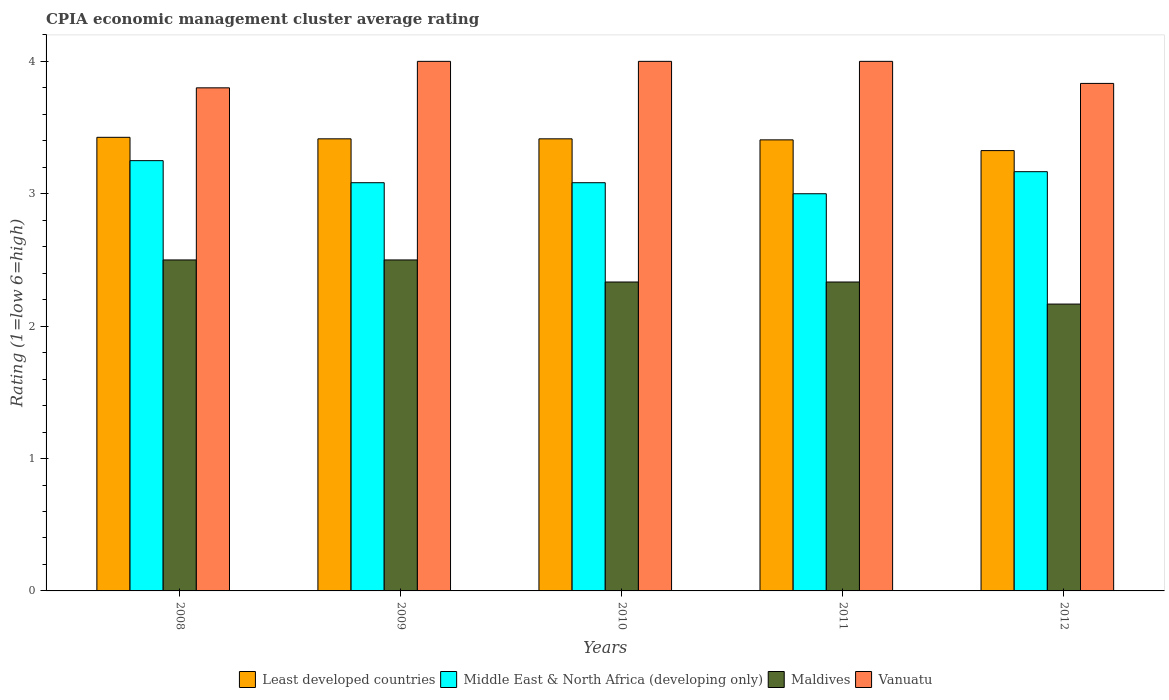How many different coloured bars are there?
Your response must be concise. 4. What is the CPIA rating in Vanuatu in 2011?
Provide a short and direct response. 4. Across all years, what is the maximum CPIA rating in Maldives?
Provide a succinct answer. 2.5. Across all years, what is the minimum CPIA rating in Maldives?
Your response must be concise. 2.17. In which year was the CPIA rating in Vanuatu maximum?
Provide a succinct answer. 2009. In which year was the CPIA rating in Vanuatu minimum?
Offer a very short reply. 2008. What is the total CPIA rating in Least developed countries in the graph?
Keep it short and to the point. 16.99. What is the difference between the CPIA rating in Vanuatu in 2010 and that in 2012?
Your response must be concise. 0.17. What is the average CPIA rating in Maldives per year?
Provide a short and direct response. 2.37. In the year 2011, what is the difference between the CPIA rating in Middle East & North Africa (developing only) and CPIA rating in Least developed countries?
Keep it short and to the point. -0.41. In how many years, is the CPIA rating in Least developed countries greater than 1.6?
Give a very brief answer. 5. What is the ratio of the CPIA rating in Maldives in 2010 to that in 2012?
Your answer should be compact. 1.08. What is the difference between the highest and the second highest CPIA rating in Least developed countries?
Your response must be concise. 0.01. Is the sum of the CPIA rating in Least developed countries in 2011 and 2012 greater than the maximum CPIA rating in Middle East & North Africa (developing only) across all years?
Provide a succinct answer. Yes. What does the 1st bar from the left in 2008 represents?
Your response must be concise. Least developed countries. What does the 4th bar from the right in 2010 represents?
Keep it short and to the point. Least developed countries. How many bars are there?
Provide a succinct answer. 20. Are all the bars in the graph horizontal?
Provide a short and direct response. No. How many years are there in the graph?
Your answer should be very brief. 5. What is the title of the graph?
Offer a terse response. CPIA economic management cluster average rating. Does "Congo (Republic)" appear as one of the legend labels in the graph?
Keep it short and to the point. No. What is the label or title of the X-axis?
Your answer should be very brief. Years. What is the label or title of the Y-axis?
Your response must be concise. Rating (1=low 6=high). What is the Rating (1=low 6=high) in Least developed countries in 2008?
Keep it short and to the point. 3.43. What is the Rating (1=low 6=high) in Middle East & North Africa (developing only) in 2008?
Make the answer very short. 3.25. What is the Rating (1=low 6=high) in Maldives in 2008?
Offer a terse response. 2.5. What is the Rating (1=low 6=high) in Vanuatu in 2008?
Provide a short and direct response. 3.8. What is the Rating (1=low 6=high) in Least developed countries in 2009?
Provide a succinct answer. 3.41. What is the Rating (1=low 6=high) in Middle East & North Africa (developing only) in 2009?
Make the answer very short. 3.08. What is the Rating (1=low 6=high) in Maldives in 2009?
Your answer should be very brief. 2.5. What is the Rating (1=low 6=high) in Least developed countries in 2010?
Give a very brief answer. 3.41. What is the Rating (1=low 6=high) of Middle East & North Africa (developing only) in 2010?
Provide a succinct answer. 3.08. What is the Rating (1=low 6=high) in Maldives in 2010?
Offer a very short reply. 2.33. What is the Rating (1=low 6=high) in Least developed countries in 2011?
Your answer should be very brief. 3.41. What is the Rating (1=low 6=high) in Middle East & North Africa (developing only) in 2011?
Offer a terse response. 3. What is the Rating (1=low 6=high) of Maldives in 2011?
Ensure brevity in your answer.  2.33. What is the Rating (1=low 6=high) in Vanuatu in 2011?
Provide a short and direct response. 4. What is the Rating (1=low 6=high) in Least developed countries in 2012?
Offer a terse response. 3.33. What is the Rating (1=low 6=high) in Middle East & North Africa (developing only) in 2012?
Your answer should be very brief. 3.17. What is the Rating (1=low 6=high) of Maldives in 2012?
Make the answer very short. 2.17. What is the Rating (1=low 6=high) of Vanuatu in 2012?
Your answer should be very brief. 3.83. Across all years, what is the maximum Rating (1=low 6=high) of Least developed countries?
Ensure brevity in your answer.  3.43. Across all years, what is the maximum Rating (1=low 6=high) of Middle East & North Africa (developing only)?
Your answer should be very brief. 3.25. Across all years, what is the maximum Rating (1=low 6=high) of Vanuatu?
Keep it short and to the point. 4. Across all years, what is the minimum Rating (1=low 6=high) of Least developed countries?
Make the answer very short. 3.33. Across all years, what is the minimum Rating (1=low 6=high) of Maldives?
Provide a short and direct response. 2.17. What is the total Rating (1=low 6=high) in Least developed countries in the graph?
Offer a very short reply. 16.99. What is the total Rating (1=low 6=high) in Middle East & North Africa (developing only) in the graph?
Keep it short and to the point. 15.58. What is the total Rating (1=low 6=high) of Maldives in the graph?
Give a very brief answer. 11.83. What is the total Rating (1=low 6=high) in Vanuatu in the graph?
Make the answer very short. 19.63. What is the difference between the Rating (1=low 6=high) of Least developed countries in 2008 and that in 2009?
Your response must be concise. 0.01. What is the difference between the Rating (1=low 6=high) in Least developed countries in 2008 and that in 2010?
Offer a very short reply. 0.01. What is the difference between the Rating (1=low 6=high) of Middle East & North Africa (developing only) in 2008 and that in 2010?
Your response must be concise. 0.17. What is the difference between the Rating (1=low 6=high) of Vanuatu in 2008 and that in 2010?
Your answer should be compact. -0.2. What is the difference between the Rating (1=low 6=high) in Least developed countries in 2008 and that in 2011?
Provide a succinct answer. 0.02. What is the difference between the Rating (1=low 6=high) in Maldives in 2008 and that in 2011?
Give a very brief answer. 0.17. What is the difference between the Rating (1=low 6=high) of Least developed countries in 2008 and that in 2012?
Your response must be concise. 0.1. What is the difference between the Rating (1=low 6=high) in Middle East & North Africa (developing only) in 2008 and that in 2012?
Ensure brevity in your answer.  0.08. What is the difference between the Rating (1=low 6=high) in Vanuatu in 2008 and that in 2012?
Your response must be concise. -0.03. What is the difference between the Rating (1=low 6=high) in Least developed countries in 2009 and that in 2010?
Ensure brevity in your answer.  0. What is the difference between the Rating (1=low 6=high) of Middle East & North Africa (developing only) in 2009 and that in 2010?
Provide a succinct answer. 0. What is the difference between the Rating (1=low 6=high) of Vanuatu in 2009 and that in 2010?
Your answer should be very brief. 0. What is the difference between the Rating (1=low 6=high) of Least developed countries in 2009 and that in 2011?
Provide a short and direct response. 0.01. What is the difference between the Rating (1=low 6=high) of Middle East & North Africa (developing only) in 2009 and that in 2011?
Offer a very short reply. 0.08. What is the difference between the Rating (1=low 6=high) of Maldives in 2009 and that in 2011?
Offer a terse response. 0.17. What is the difference between the Rating (1=low 6=high) in Least developed countries in 2009 and that in 2012?
Your answer should be compact. 0.09. What is the difference between the Rating (1=low 6=high) of Middle East & North Africa (developing only) in 2009 and that in 2012?
Ensure brevity in your answer.  -0.08. What is the difference between the Rating (1=low 6=high) in Least developed countries in 2010 and that in 2011?
Your response must be concise. 0.01. What is the difference between the Rating (1=low 6=high) of Middle East & North Africa (developing only) in 2010 and that in 2011?
Keep it short and to the point. 0.08. What is the difference between the Rating (1=low 6=high) of Least developed countries in 2010 and that in 2012?
Offer a very short reply. 0.09. What is the difference between the Rating (1=low 6=high) in Middle East & North Africa (developing only) in 2010 and that in 2012?
Your answer should be very brief. -0.08. What is the difference between the Rating (1=low 6=high) in Maldives in 2010 and that in 2012?
Make the answer very short. 0.17. What is the difference between the Rating (1=low 6=high) of Vanuatu in 2010 and that in 2012?
Offer a very short reply. 0.17. What is the difference between the Rating (1=low 6=high) in Least developed countries in 2011 and that in 2012?
Give a very brief answer. 0.08. What is the difference between the Rating (1=low 6=high) of Maldives in 2011 and that in 2012?
Offer a terse response. 0.17. What is the difference between the Rating (1=low 6=high) in Vanuatu in 2011 and that in 2012?
Offer a very short reply. 0.17. What is the difference between the Rating (1=low 6=high) of Least developed countries in 2008 and the Rating (1=low 6=high) of Middle East & North Africa (developing only) in 2009?
Ensure brevity in your answer.  0.34. What is the difference between the Rating (1=low 6=high) in Least developed countries in 2008 and the Rating (1=low 6=high) in Maldives in 2009?
Give a very brief answer. 0.93. What is the difference between the Rating (1=low 6=high) of Least developed countries in 2008 and the Rating (1=low 6=high) of Vanuatu in 2009?
Provide a succinct answer. -0.57. What is the difference between the Rating (1=low 6=high) in Middle East & North Africa (developing only) in 2008 and the Rating (1=low 6=high) in Vanuatu in 2009?
Keep it short and to the point. -0.75. What is the difference between the Rating (1=low 6=high) in Maldives in 2008 and the Rating (1=low 6=high) in Vanuatu in 2009?
Make the answer very short. -1.5. What is the difference between the Rating (1=low 6=high) in Least developed countries in 2008 and the Rating (1=low 6=high) in Middle East & North Africa (developing only) in 2010?
Provide a short and direct response. 0.34. What is the difference between the Rating (1=low 6=high) of Least developed countries in 2008 and the Rating (1=low 6=high) of Maldives in 2010?
Keep it short and to the point. 1.09. What is the difference between the Rating (1=low 6=high) in Least developed countries in 2008 and the Rating (1=low 6=high) in Vanuatu in 2010?
Provide a short and direct response. -0.57. What is the difference between the Rating (1=low 6=high) of Middle East & North Africa (developing only) in 2008 and the Rating (1=low 6=high) of Maldives in 2010?
Keep it short and to the point. 0.92. What is the difference between the Rating (1=low 6=high) of Middle East & North Africa (developing only) in 2008 and the Rating (1=low 6=high) of Vanuatu in 2010?
Provide a short and direct response. -0.75. What is the difference between the Rating (1=low 6=high) of Least developed countries in 2008 and the Rating (1=low 6=high) of Middle East & North Africa (developing only) in 2011?
Your answer should be compact. 0.43. What is the difference between the Rating (1=low 6=high) of Least developed countries in 2008 and the Rating (1=low 6=high) of Maldives in 2011?
Your answer should be compact. 1.09. What is the difference between the Rating (1=low 6=high) in Least developed countries in 2008 and the Rating (1=low 6=high) in Vanuatu in 2011?
Ensure brevity in your answer.  -0.57. What is the difference between the Rating (1=low 6=high) in Middle East & North Africa (developing only) in 2008 and the Rating (1=low 6=high) in Maldives in 2011?
Keep it short and to the point. 0.92. What is the difference between the Rating (1=low 6=high) in Middle East & North Africa (developing only) in 2008 and the Rating (1=low 6=high) in Vanuatu in 2011?
Give a very brief answer. -0.75. What is the difference between the Rating (1=low 6=high) in Maldives in 2008 and the Rating (1=low 6=high) in Vanuatu in 2011?
Offer a terse response. -1.5. What is the difference between the Rating (1=low 6=high) in Least developed countries in 2008 and the Rating (1=low 6=high) in Middle East & North Africa (developing only) in 2012?
Ensure brevity in your answer.  0.26. What is the difference between the Rating (1=low 6=high) in Least developed countries in 2008 and the Rating (1=low 6=high) in Maldives in 2012?
Offer a terse response. 1.26. What is the difference between the Rating (1=low 6=high) in Least developed countries in 2008 and the Rating (1=low 6=high) in Vanuatu in 2012?
Ensure brevity in your answer.  -0.41. What is the difference between the Rating (1=low 6=high) in Middle East & North Africa (developing only) in 2008 and the Rating (1=low 6=high) in Maldives in 2012?
Keep it short and to the point. 1.08. What is the difference between the Rating (1=low 6=high) of Middle East & North Africa (developing only) in 2008 and the Rating (1=low 6=high) of Vanuatu in 2012?
Offer a very short reply. -0.58. What is the difference between the Rating (1=low 6=high) of Maldives in 2008 and the Rating (1=low 6=high) of Vanuatu in 2012?
Your response must be concise. -1.33. What is the difference between the Rating (1=low 6=high) in Least developed countries in 2009 and the Rating (1=low 6=high) in Middle East & North Africa (developing only) in 2010?
Provide a succinct answer. 0.33. What is the difference between the Rating (1=low 6=high) in Least developed countries in 2009 and the Rating (1=low 6=high) in Maldives in 2010?
Your answer should be very brief. 1.08. What is the difference between the Rating (1=low 6=high) in Least developed countries in 2009 and the Rating (1=low 6=high) in Vanuatu in 2010?
Ensure brevity in your answer.  -0.59. What is the difference between the Rating (1=low 6=high) of Middle East & North Africa (developing only) in 2009 and the Rating (1=low 6=high) of Maldives in 2010?
Ensure brevity in your answer.  0.75. What is the difference between the Rating (1=low 6=high) in Middle East & North Africa (developing only) in 2009 and the Rating (1=low 6=high) in Vanuatu in 2010?
Ensure brevity in your answer.  -0.92. What is the difference between the Rating (1=low 6=high) in Least developed countries in 2009 and the Rating (1=low 6=high) in Middle East & North Africa (developing only) in 2011?
Offer a terse response. 0.41. What is the difference between the Rating (1=low 6=high) of Least developed countries in 2009 and the Rating (1=low 6=high) of Maldives in 2011?
Offer a very short reply. 1.08. What is the difference between the Rating (1=low 6=high) in Least developed countries in 2009 and the Rating (1=low 6=high) in Vanuatu in 2011?
Ensure brevity in your answer.  -0.59. What is the difference between the Rating (1=low 6=high) of Middle East & North Africa (developing only) in 2009 and the Rating (1=low 6=high) of Vanuatu in 2011?
Keep it short and to the point. -0.92. What is the difference between the Rating (1=low 6=high) in Maldives in 2009 and the Rating (1=low 6=high) in Vanuatu in 2011?
Your answer should be compact. -1.5. What is the difference between the Rating (1=low 6=high) in Least developed countries in 2009 and the Rating (1=low 6=high) in Middle East & North Africa (developing only) in 2012?
Your answer should be compact. 0.25. What is the difference between the Rating (1=low 6=high) in Least developed countries in 2009 and the Rating (1=low 6=high) in Maldives in 2012?
Make the answer very short. 1.25. What is the difference between the Rating (1=low 6=high) in Least developed countries in 2009 and the Rating (1=low 6=high) in Vanuatu in 2012?
Ensure brevity in your answer.  -0.42. What is the difference between the Rating (1=low 6=high) in Middle East & North Africa (developing only) in 2009 and the Rating (1=low 6=high) in Maldives in 2012?
Offer a terse response. 0.92. What is the difference between the Rating (1=low 6=high) of Middle East & North Africa (developing only) in 2009 and the Rating (1=low 6=high) of Vanuatu in 2012?
Make the answer very short. -0.75. What is the difference between the Rating (1=low 6=high) of Maldives in 2009 and the Rating (1=low 6=high) of Vanuatu in 2012?
Provide a short and direct response. -1.33. What is the difference between the Rating (1=low 6=high) of Least developed countries in 2010 and the Rating (1=low 6=high) of Middle East & North Africa (developing only) in 2011?
Ensure brevity in your answer.  0.41. What is the difference between the Rating (1=low 6=high) in Least developed countries in 2010 and the Rating (1=low 6=high) in Maldives in 2011?
Give a very brief answer. 1.08. What is the difference between the Rating (1=low 6=high) in Least developed countries in 2010 and the Rating (1=low 6=high) in Vanuatu in 2011?
Provide a short and direct response. -0.59. What is the difference between the Rating (1=low 6=high) in Middle East & North Africa (developing only) in 2010 and the Rating (1=low 6=high) in Vanuatu in 2011?
Your response must be concise. -0.92. What is the difference between the Rating (1=low 6=high) of Maldives in 2010 and the Rating (1=low 6=high) of Vanuatu in 2011?
Make the answer very short. -1.67. What is the difference between the Rating (1=low 6=high) of Least developed countries in 2010 and the Rating (1=low 6=high) of Middle East & North Africa (developing only) in 2012?
Your response must be concise. 0.25. What is the difference between the Rating (1=low 6=high) in Least developed countries in 2010 and the Rating (1=low 6=high) in Maldives in 2012?
Offer a terse response. 1.25. What is the difference between the Rating (1=low 6=high) of Least developed countries in 2010 and the Rating (1=low 6=high) of Vanuatu in 2012?
Your answer should be very brief. -0.42. What is the difference between the Rating (1=low 6=high) in Middle East & North Africa (developing only) in 2010 and the Rating (1=low 6=high) in Maldives in 2012?
Your answer should be very brief. 0.92. What is the difference between the Rating (1=low 6=high) of Middle East & North Africa (developing only) in 2010 and the Rating (1=low 6=high) of Vanuatu in 2012?
Make the answer very short. -0.75. What is the difference between the Rating (1=low 6=high) in Maldives in 2010 and the Rating (1=low 6=high) in Vanuatu in 2012?
Provide a short and direct response. -1.5. What is the difference between the Rating (1=low 6=high) of Least developed countries in 2011 and the Rating (1=low 6=high) of Middle East & North Africa (developing only) in 2012?
Your answer should be very brief. 0.24. What is the difference between the Rating (1=low 6=high) in Least developed countries in 2011 and the Rating (1=low 6=high) in Maldives in 2012?
Your answer should be compact. 1.24. What is the difference between the Rating (1=low 6=high) in Least developed countries in 2011 and the Rating (1=low 6=high) in Vanuatu in 2012?
Offer a very short reply. -0.43. What is the difference between the Rating (1=low 6=high) in Middle East & North Africa (developing only) in 2011 and the Rating (1=low 6=high) in Maldives in 2012?
Make the answer very short. 0.83. What is the difference between the Rating (1=low 6=high) in Middle East & North Africa (developing only) in 2011 and the Rating (1=low 6=high) in Vanuatu in 2012?
Your answer should be very brief. -0.83. What is the average Rating (1=low 6=high) of Least developed countries per year?
Provide a succinct answer. 3.4. What is the average Rating (1=low 6=high) of Middle East & North Africa (developing only) per year?
Give a very brief answer. 3.12. What is the average Rating (1=low 6=high) in Maldives per year?
Offer a terse response. 2.37. What is the average Rating (1=low 6=high) of Vanuatu per year?
Offer a terse response. 3.93. In the year 2008, what is the difference between the Rating (1=low 6=high) of Least developed countries and Rating (1=low 6=high) of Middle East & North Africa (developing only)?
Provide a succinct answer. 0.18. In the year 2008, what is the difference between the Rating (1=low 6=high) in Least developed countries and Rating (1=low 6=high) in Maldives?
Offer a very short reply. 0.93. In the year 2008, what is the difference between the Rating (1=low 6=high) in Least developed countries and Rating (1=low 6=high) in Vanuatu?
Offer a terse response. -0.37. In the year 2008, what is the difference between the Rating (1=low 6=high) in Middle East & North Africa (developing only) and Rating (1=low 6=high) in Maldives?
Provide a succinct answer. 0.75. In the year 2008, what is the difference between the Rating (1=low 6=high) in Middle East & North Africa (developing only) and Rating (1=low 6=high) in Vanuatu?
Offer a very short reply. -0.55. In the year 2009, what is the difference between the Rating (1=low 6=high) of Least developed countries and Rating (1=low 6=high) of Middle East & North Africa (developing only)?
Offer a very short reply. 0.33. In the year 2009, what is the difference between the Rating (1=low 6=high) of Least developed countries and Rating (1=low 6=high) of Maldives?
Keep it short and to the point. 0.91. In the year 2009, what is the difference between the Rating (1=low 6=high) in Least developed countries and Rating (1=low 6=high) in Vanuatu?
Provide a short and direct response. -0.59. In the year 2009, what is the difference between the Rating (1=low 6=high) of Middle East & North Africa (developing only) and Rating (1=low 6=high) of Maldives?
Provide a short and direct response. 0.58. In the year 2009, what is the difference between the Rating (1=low 6=high) in Middle East & North Africa (developing only) and Rating (1=low 6=high) in Vanuatu?
Ensure brevity in your answer.  -0.92. In the year 2010, what is the difference between the Rating (1=low 6=high) of Least developed countries and Rating (1=low 6=high) of Middle East & North Africa (developing only)?
Make the answer very short. 0.33. In the year 2010, what is the difference between the Rating (1=low 6=high) of Least developed countries and Rating (1=low 6=high) of Maldives?
Provide a short and direct response. 1.08. In the year 2010, what is the difference between the Rating (1=low 6=high) of Least developed countries and Rating (1=low 6=high) of Vanuatu?
Ensure brevity in your answer.  -0.59. In the year 2010, what is the difference between the Rating (1=low 6=high) in Middle East & North Africa (developing only) and Rating (1=low 6=high) in Vanuatu?
Offer a very short reply. -0.92. In the year 2010, what is the difference between the Rating (1=low 6=high) in Maldives and Rating (1=low 6=high) in Vanuatu?
Provide a short and direct response. -1.67. In the year 2011, what is the difference between the Rating (1=low 6=high) of Least developed countries and Rating (1=low 6=high) of Middle East & North Africa (developing only)?
Provide a succinct answer. 0.41. In the year 2011, what is the difference between the Rating (1=low 6=high) of Least developed countries and Rating (1=low 6=high) of Maldives?
Offer a terse response. 1.07. In the year 2011, what is the difference between the Rating (1=low 6=high) in Least developed countries and Rating (1=low 6=high) in Vanuatu?
Ensure brevity in your answer.  -0.59. In the year 2011, what is the difference between the Rating (1=low 6=high) in Middle East & North Africa (developing only) and Rating (1=low 6=high) in Vanuatu?
Offer a very short reply. -1. In the year 2011, what is the difference between the Rating (1=low 6=high) in Maldives and Rating (1=low 6=high) in Vanuatu?
Provide a short and direct response. -1.67. In the year 2012, what is the difference between the Rating (1=low 6=high) in Least developed countries and Rating (1=low 6=high) in Middle East & North Africa (developing only)?
Your answer should be very brief. 0.16. In the year 2012, what is the difference between the Rating (1=low 6=high) in Least developed countries and Rating (1=low 6=high) in Maldives?
Offer a terse response. 1.16. In the year 2012, what is the difference between the Rating (1=low 6=high) of Least developed countries and Rating (1=low 6=high) of Vanuatu?
Your answer should be very brief. -0.51. In the year 2012, what is the difference between the Rating (1=low 6=high) of Maldives and Rating (1=low 6=high) of Vanuatu?
Give a very brief answer. -1.67. What is the ratio of the Rating (1=low 6=high) of Middle East & North Africa (developing only) in 2008 to that in 2009?
Provide a short and direct response. 1.05. What is the ratio of the Rating (1=low 6=high) in Maldives in 2008 to that in 2009?
Provide a succinct answer. 1. What is the ratio of the Rating (1=low 6=high) in Vanuatu in 2008 to that in 2009?
Offer a terse response. 0.95. What is the ratio of the Rating (1=low 6=high) of Middle East & North Africa (developing only) in 2008 to that in 2010?
Your response must be concise. 1.05. What is the ratio of the Rating (1=low 6=high) in Maldives in 2008 to that in 2010?
Offer a terse response. 1.07. What is the ratio of the Rating (1=low 6=high) of Vanuatu in 2008 to that in 2010?
Provide a short and direct response. 0.95. What is the ratio of the Rating (1=low 6=high) of Least developed countries in 2008 to that in 2011?
Make the answer very short. 1.01. What is the ratio of the Rating (1=low 6=high) in Middle East & North Africa (developing only) in 2008 to that in 2011?
Offer a terse response. 1.08. What is the ratio of the Rating (1=low 6=high) in Maldives in 2008 to that in 2011?
Your answer should be very brief. 1.07. What is the ratio of the Rating (1=low 6=high) in Vanuatu in 2008 to that in 2011?
Your response must be concise. 0.95. What is the ratio of the Rating (1=low 6=high) in Least developed countries in 2008 to that in 2012?
Provide a short and direct response. 1.03. What is the ratio of the Rating (1=low 6=high) in Middle East & North Africa (developing only) in 2008 to that in 2012?
Your response must be concise. 1.03. What is the ratio of the Rating (1=low 6=high) of Maldives in 2008 to that in 2012?
Make the answer very short. 1.15. What is the ratio of the Rating (1=low 6=high) in Vanuatu in 2008 to that in 2012?
Offer a terse response. 0.99. What is the ratio of the Rating (1=low 6=high) in Middle East & North Africa (developing only) in 2009 to that in 2010?
Offer a terse response. 1. What is the ratio of the Rating (1=low 6=high) in Maldives in 2009 to that in 2010?
Your answer should be very brief. 1.07. What is the ratio of the Rating (1=low 6=high) in Vanuatu in 2009 to that in 2010?
Provide a short and direct response. 1. What is the ratio of the Rating (1=low 6=high) of Least developed countries in 2009 to that in 2011?
Keep it short and to the point. 1. What is the ratio of the Rating (1=low 6=high) of Middle East & North Africa (developing only) in 2009 to that in 2011?
Provide a succinct answer. 1.03. What is the ratio of the Rating (1=low 6=high) in Maldives in 2009 to that in 2011?
Your response must be concise. 1.07. What is the ratio of the Rating (1=low 6=high) in Least developed countries in 2009 to that in 2012?
Offer a very short reply. 1.03. What is the ratio of the Rating (1=low 6=high) in Middle East & North Africa (developing only) in 2009 to that in 2012?
Offer a very short reply. 0.97. What is the ratio of the Rating (1=low 6=high) in Maldives in 2009 to that in 2012?
Offer a very short reply. 1.15. What is the ratio of the Rating (1=low 6=high) of Vanuatu in 2009 to that in 2012?
Offer a terse response. 1.04. What is the ratio of the Rating (1=low 6=high) of Least developed countries in 2010 to that in 2011?
Provide a succinct answer. 1. What is the ratio of the Rating (1=low 6=high) of Middle East & North Africa (developing only) in 2010 to that in 2011?
Make the answer very short. 1.03. What is the ratio of the Rating (1=low 6=high) of Least developed countries in 2010 to that in 2012?
Provide a succinct answer. 1.03. What is the ratio of the Rating (1=low 6=high) of Middle East & North Africa (developing only) in 2010 to that in 2012?
Offer a terse response. 0.97. What is the ratio of the Rating (1=low 6=high) of Vanuatu in 2010 to that in 2012?
Offer a terse response. 1.04. What is the ratio of the Rating (1=low 6=high) in Least developed countries in 2011 to that in 2012?
Make the answer very short. 1.02. What is the ratio of the Rating (1=low 6=high) in Vanuatu in 2011 to that in 2012?
Provide a succinct answer. 1.04. What is the difference between the highest and the second highest Rating (1=low 6=high) of Least developed countries?
Provide a short and direct response. 0.01. What is the difference between the highest and the second highest Rating (1=low 6=high) of Middle East & North Africa (developing only)?
Your answer should be compact. 0.08. What is the difference between the highest and the second highest Rating (1=low 6=high) of Maldives?
Offer a very short reply. 0. What is the difference between the highest and the lowest Rating (1=low 6=high) of Least developed countries?
Offer a very short reply. 0.1. What is the difference between the highest and the lowest Rating (1=low 6=high) in Maldives?
Provide a short and direct response. 0.33. 